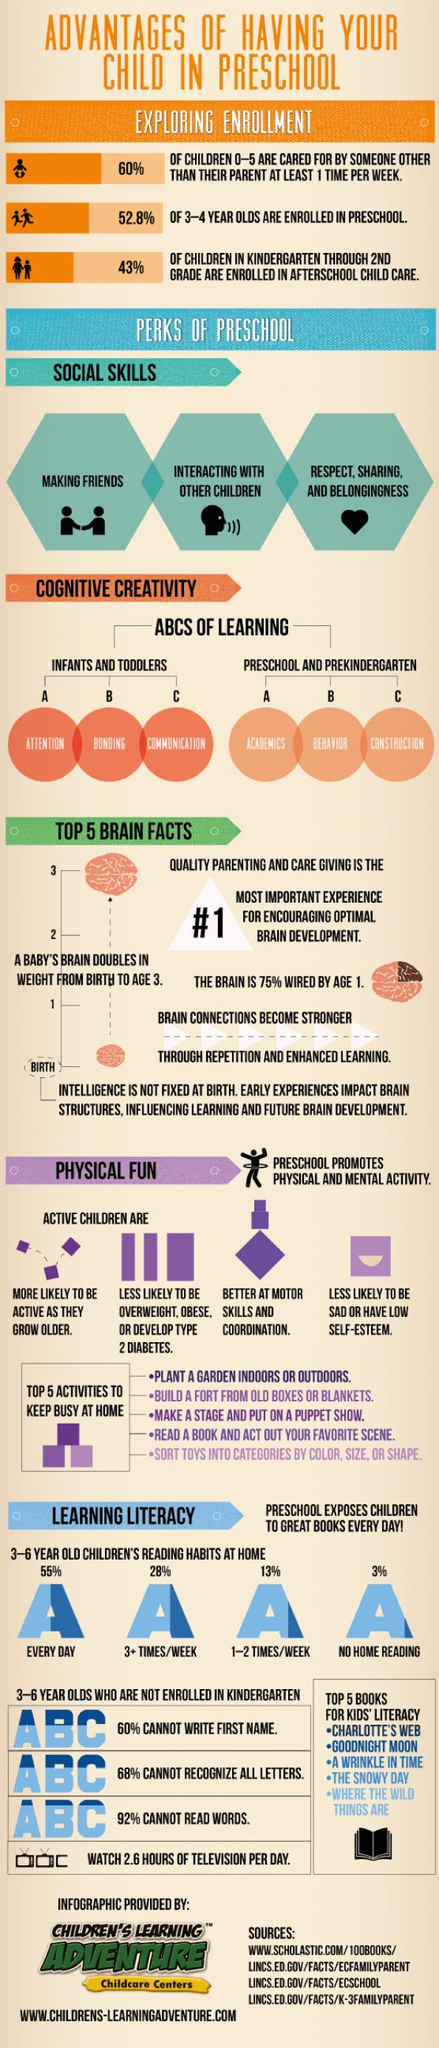Specify some key components in this picture. The development of social skills from preschool can be estimated to be around 3. According to the given data, it is evident that only 13% of children read 1-2 times per week. The baby's brain will double in size in approximately three years. The children who are likely to remain active as they grow older are the active children. The book image is black. 